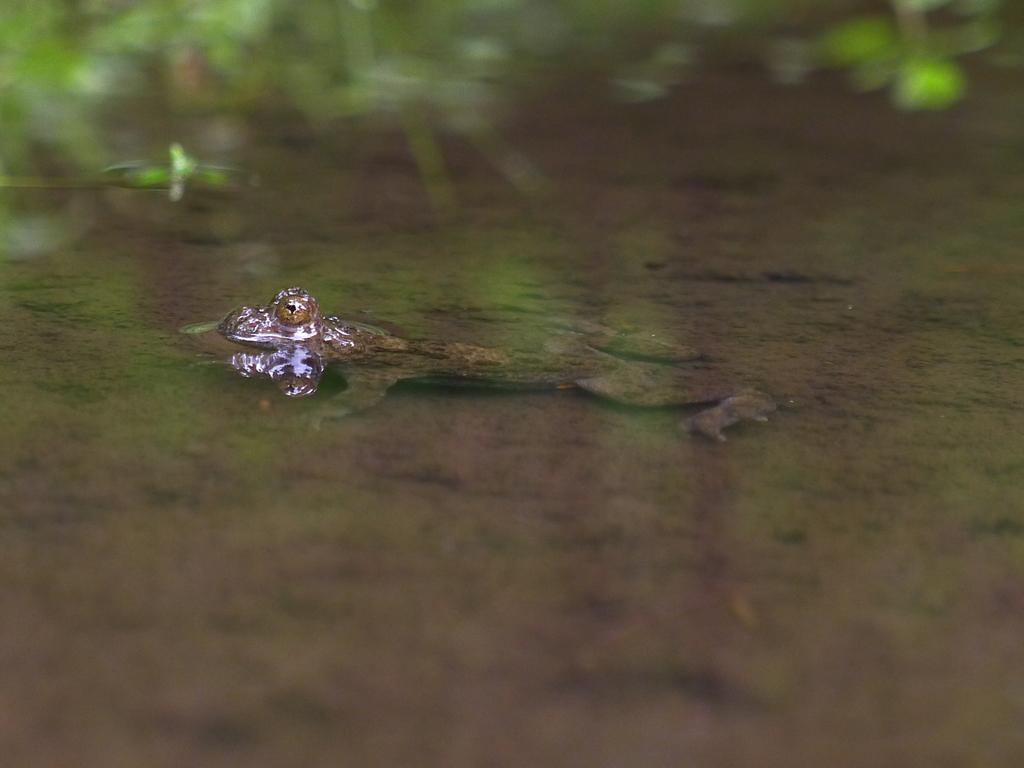What type of animal is in the image? There is a frog in the image. What else can be seen in the image besides the frog? There is algae in the image. How would you describe the background of the image? The background of the image is blurry and green. How many wings does the frog have in the image? Frogs do not have wings, so the frog in the image does not have any wings. 